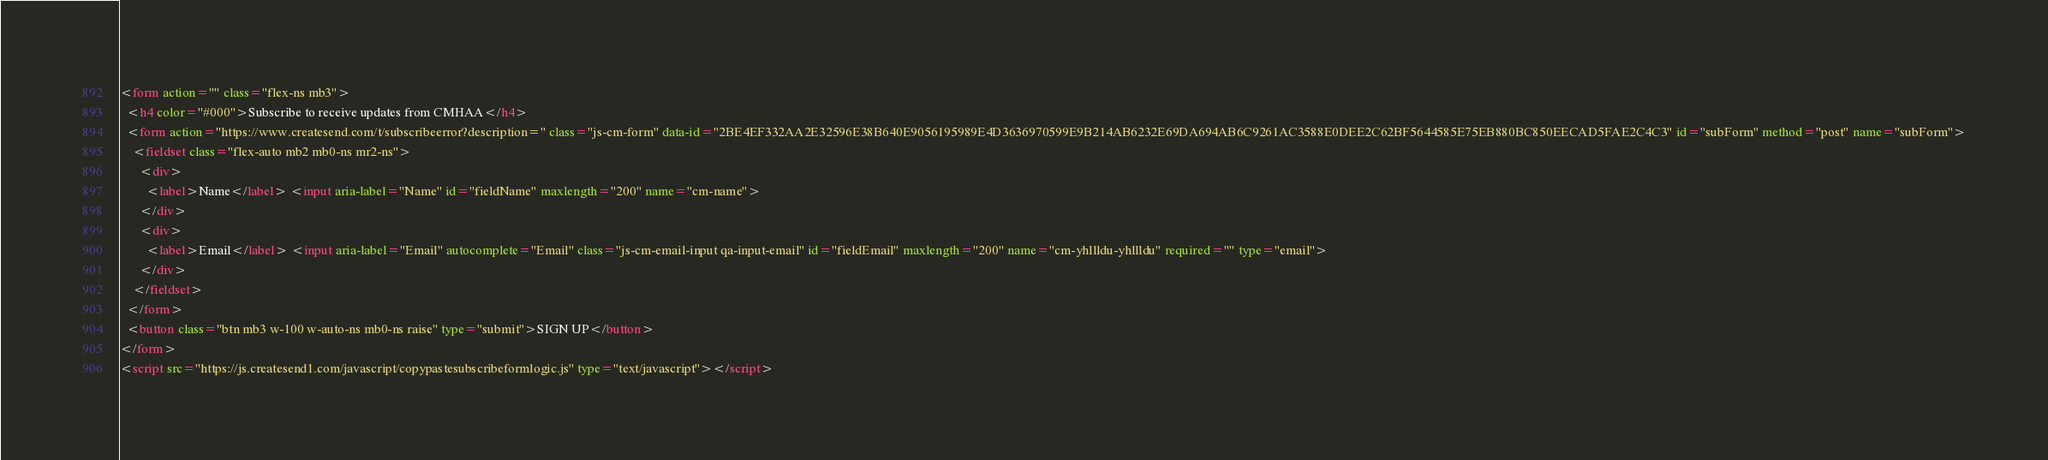Convert code to text. <code><loc_0><loc_0><loc_500><loc_500><_HTML_><form action="" class="flex-ns mb3">
  <h4 color="#000">Subscribe to receive updates from CMHAA</h4>
  <form action="https://www.createsend.com/t/subscribeerror?description=" class="js-cm-form" data-id="2BE4EF332AA2E32596E38B640E9056195989E4D3636970599E9B214AB6232E69DA694AB6C9261AC3588E0DEE2C62BF5644585E75EB880BC850EECAD5FAE2C4C3" id="subForm" method="post" name="subForm">
    <fieldset class="flex-auto mb2 mb0-ns mr2-ns">
      <div>
        <label>Name</label> <input aria-label="Name" id="fieldName" maxlength="200" name="cm-name">
      </div>
      <div>
        <label>Email</label> <input aria-label="Email" autocomplete="Email" class="js-cm-email-input qa-input-email" id="fieldEmail" maxlength="200" name="cm-yhllldu-yhllldu" required="" type="email">
      </div>
    </fieldset>
  </form>
  <button class="btn mb3 w-100 w-auto-ns mb0-ns raise" type="submit">SIGN UP</button>
</form>
<script src="https://js.createsend1.com/javascript/copypastesubscribeformlogic.js" type="text/javascript"></script>


</code> 